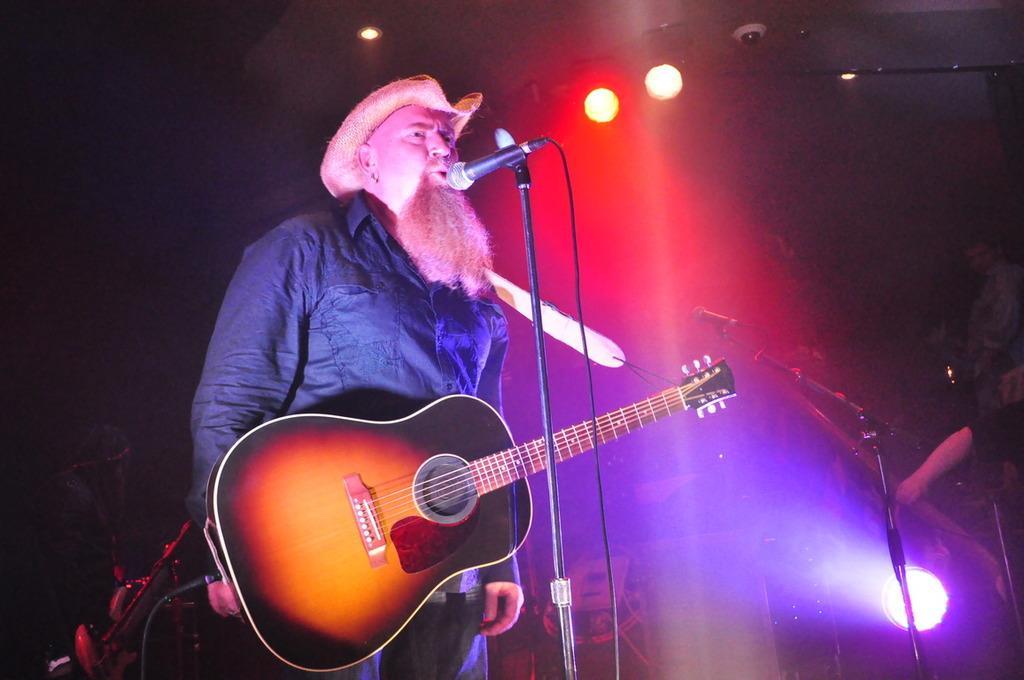Describe this image in one or two sentences. In the picture I can see a person wearing the shirt and hat is carrying a guitar and standing near the mic which is fixed to the stand. The background of the image is dark, where we can see show lights and we can see a person on the right side of the image. 